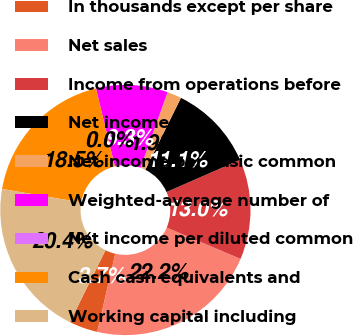Convert chart. <chart><loc_0><loc_0><loc_500><loc_500><pie_chart><fcel>In thousands except per share<fcel>Net sales<fcel>Income from operations before<fcel>Net income<fcel>Net income per basic common<fcel>Weighted-average number of<fcel>Net income per diluted common<fcel>Cash cash equivalents and<fcel>Working capital including<nl><fcel>3.7%<fcel>22.22%<fcel>12.96%<fcel>11.11%<fcel>1.85%<fcel>9.26%<fcel>0.0%<fcel>18.52%<fcel>20.37%<nl></chart> 